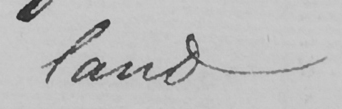Can you read and transcribe this handwriting? land 